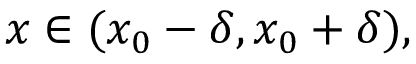Convert formula to latex. <formula><loc_0><loc_0><loc_500><loc_500>x \in ( x _ { 0 } - \delta , x _ { 0 } + \delta ) ,</formula> 